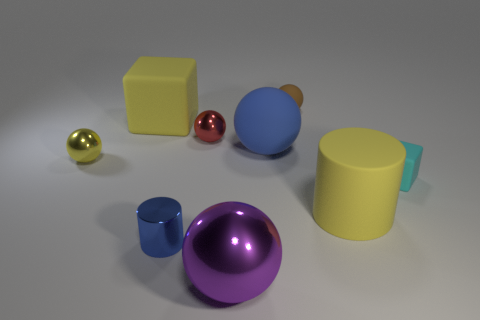Subtract all small matte balls. How many balls are left? 4 Subtract all blue balls. How many balls are left? 4 Subtract all gray balls. Subtract all yellow cubes. How many balls are left? 5 Add 1 cylinders. How many objects exist? 10 Subtract all cylinders. How many objects are left? 7 Add 2 small balls. How many small balls exist? 5 Subtract 0 blue cubes. How many objects are left? 9 Subtract all blue metal objects. Subtract all small red metallic things. How many objects are left? 7 Add 9 tiny yellow shiny balls. How many tiny yellow shiny balls are left? 10 